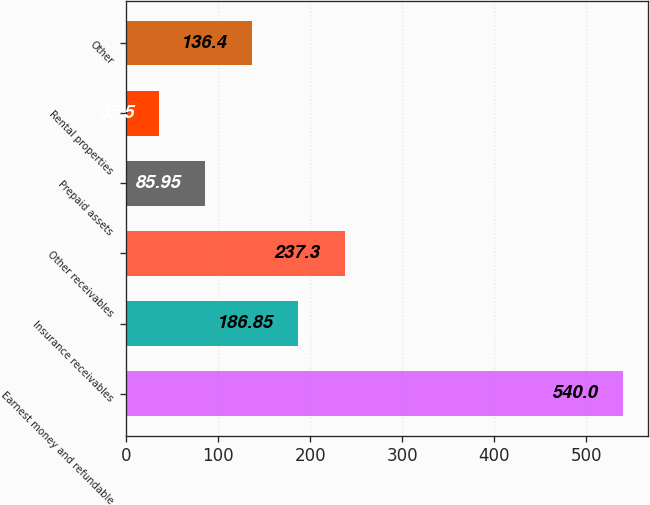<chart> <loc_0><loc_0><loc_500><loc_500><bar_chart><fcel>Earnest money and refundable<fcel>Insurance receivables<fcel>Other receivables<fcel>Prepaid assets<fcel>Rental properties<fcel>Other<nl><fcel>540<fcel>186.85<fcel>237.3<fcel>85.95<fcel>35.5<fcel>136.4<nl></chart> 